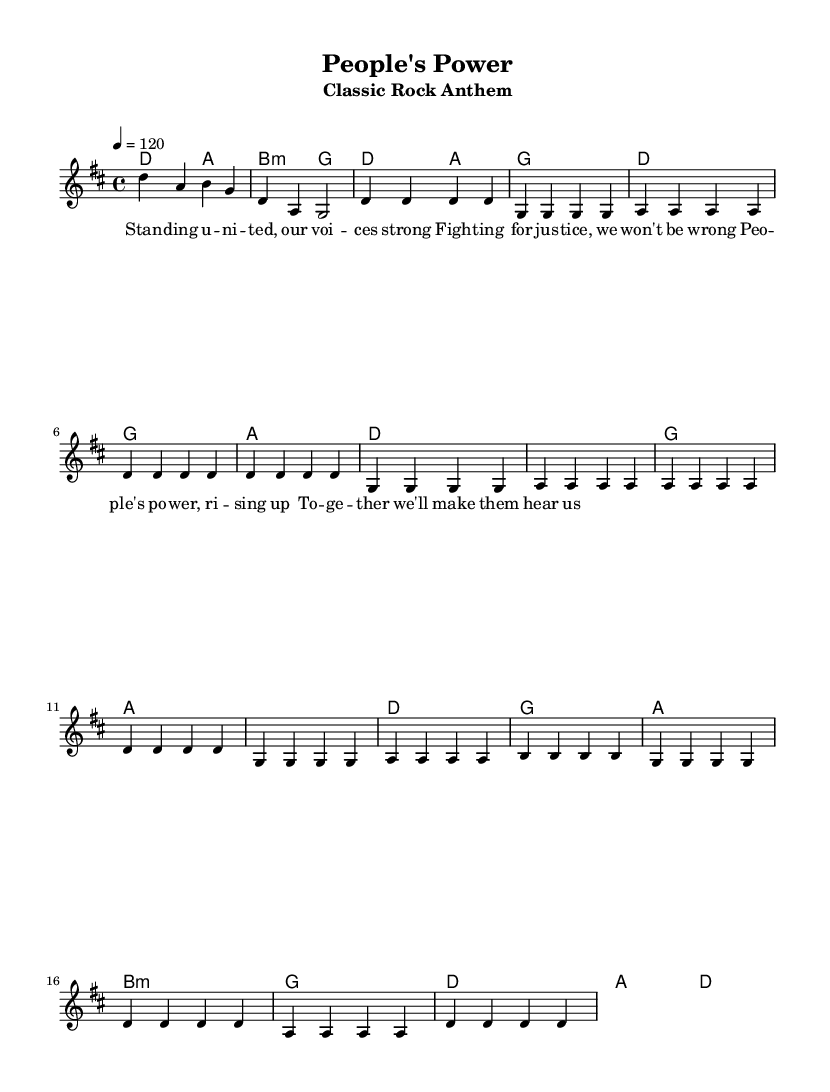What is the key signature of this music? The key signature is D major, which has two sharps: F# and C#.
Answer: D major What is the time signature of this music? The time signature is 4/4, indicating four beats per measure.
Answer: 4/4 What is the tempo marking of this music? The tempo marking is Quarter note equals 120, indicating the speed of the music.
Answer: 120 How many measures are in the chorus? The chorus consists of 8 measures, as counted from the notation provided.
Answer: 8 What is the first note in the melody? The first note in the melody is D, which appears at the beginning of the piece.
Answer: D What chords are used in the verse? The chords used in the verse are D, G, and A, based on the chord for each measure in the verse section.
Answer: D, G, A What is the lyrical theme of the song? The lyrical theme of the song revolves around unity and social justice, as reflected in the provided lyrics.
Answer: Unity and social justice 